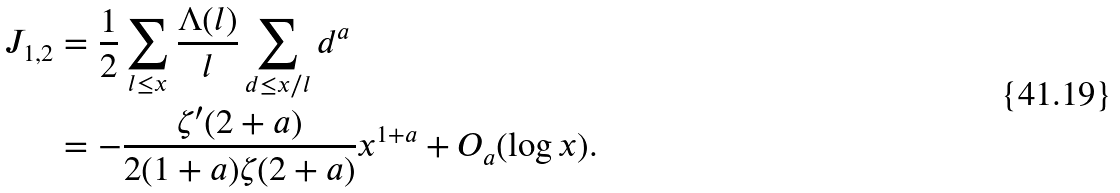<formula> <loc_0><loc_0><loc_500><loc_500>J _ { 1 , 2 } & = \frac { 1 } { 2 } \sum _ { l \leq x } \frac { \Lambda ( l ) } { l } \sum _ { d \leq x / l } d ^ { a } \\ & = - \frac { \zeta ^ { \prime } ( 2 + a ) } { 2 ( 1 + a ) \zeta ( 2 + a ) } x ^ { 1 + a } + O _ { a } ( \log x ) .</formula> 